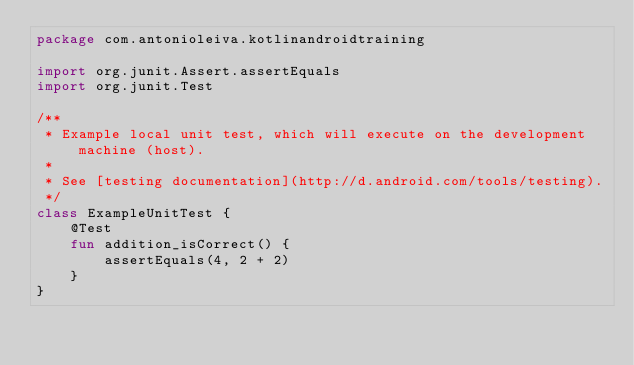<code> <loc_0><loc_0><loc_500><loc_500><_Kotlin_>package com.antonioleiva.kotlinandroidtraining

import org.junit.Assert.assertEquals
import org.junit.Test

/**
 * Example local unit test, which will execute on the development machine (host).
 *
 * See [testing documentation](http://d.android.com/tools/testing).
 */
class ExampleUnitTest {
    @Test
    fun addition_isCorrect() {
        assertEquals(4, 2 + 2)
    }
}
</code> 